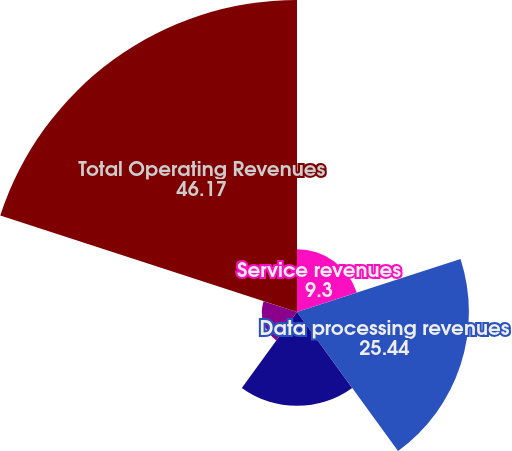<chart> <loc_0><loc_0><loc_500><loc_500><pie_chart><fcel>Service revenues<fcel>Data processing revenues<fcel>International transaction<fcel>Volume and support incentives<fcel>Total Operating Revenues<nl><fcel>9.3%<fcel>25.44%<fcel>13.89%<fcel>5.2%<fcel>46.17%<nl></chart> 